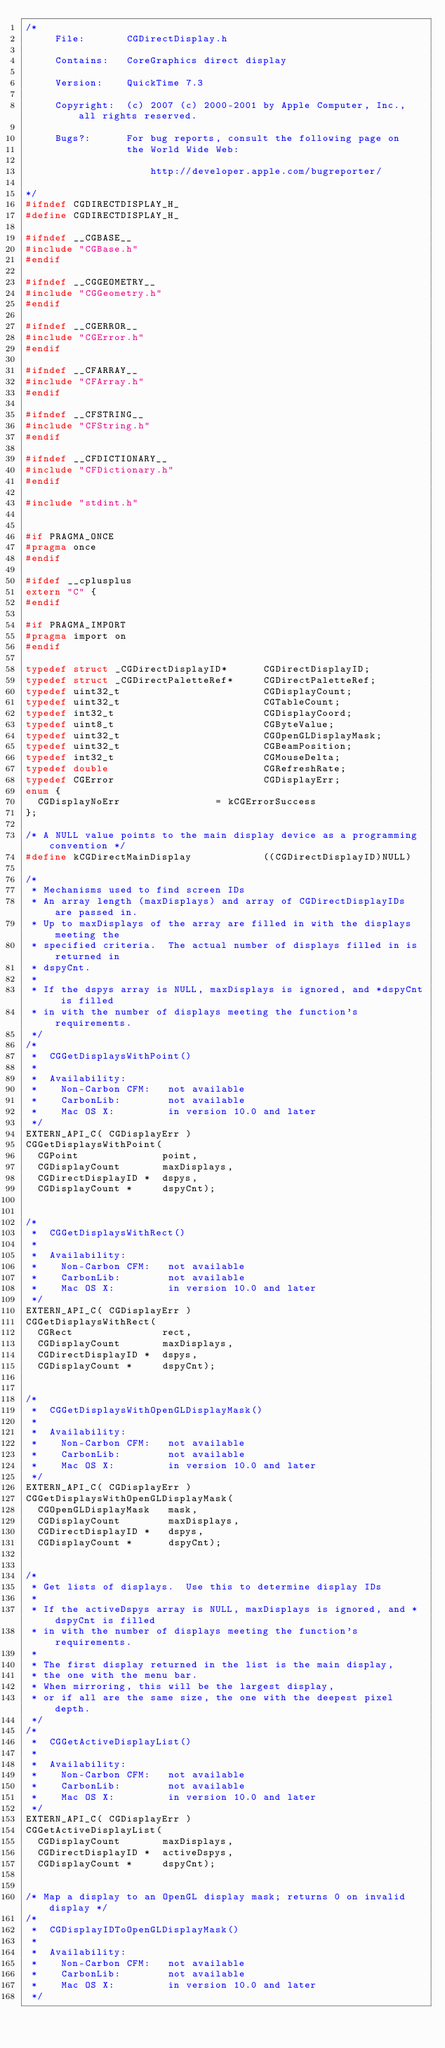Convert code to text. <code><loc_0><loc_0><loc_500><loc_500><_C_>/*
     File:       CGDirectDisplay.h
 
     Contains:   CoreGraphics direct display
 
     Version:    QuickTime 7.3
 
     Copyright:  (c) 2007 (c) 2000-2001 by Apple Computer, Inc., all rights reserved.
 
     Bugs?:      For bug reports, consult the following page on
                 the World Wide Web:
 
                     http://developer.apple.com/bugreporter/
 
*/
#ifndef CGDIRECTDISPLAY_H_
#define CGDIRECTDISPLAY_H_

#ifndef __CGBASE__
#include "CGBase.h"
#endif

#ifndef __CGGEOMETRY__
#include "CGGeometry.h"
#endif

#ifndef __CGERROR__
#include "CGError.h"
#endif

#ifndef __CFARRAY__
#include "CFArray.h"
#endif

#ifndef __CFSTRING__
#include "CFString.h"
#endif

#ifndef __CFDICTIONARY__
#include "CFDictionary.h"
#endif

#include "stdint.h"


#if PRAGMA_ONCE
#pragma once
#endif

#ifdef __cplusplus
extern "C" {
#endif

#if PRAGMA_IMPORT
#pragma import on
#endif

typedef struct _CGDirectDisplayID*      CGDirectDisplayID;
typedef struct _CGDirectPaletteRef*     CGDirectPaletteRef;
typedef uint32_t                        CGDisplayCount;
typedef uint32_t                        CGTableCount;
typedef int32_t                         CGDisplayCoord;
typedef uint8_t                         CGByteValue;
typedef uint32_t                        CGOpenGLDisplayMask;
typedef uint32_t                        CGBeamPosition;
typedef int32_t                         CGMouseDelta;
typedef double                          CGRefreshRate;
typedef CGError                         CGDisplayErr;
enum {
  CGDisplayNoErr                = kCGErrorSuccess
};

/* A NULL value points to the main display device as a programming convention */
#define kCGDirectMainDisplay            ((CGDirectDisplayID)NULL)

/*
 * Mechanisms used to find screen IDs
 * An array length (maxDisplays) and array of CGDirectDisplayIDs are passed in.
 * Up to maxDisplays of the array are filled in with the displays meeting the
 * specified criteria.  The actual number of displays filled in is returned in
 * dspyCnt.
 *
 * If the dspys array is NULL, maxDisplays is ignored, and *dspyCnt is filled
 * in with the number of displays meeting the function's requirements.
 */
/*
 *  CGGetDisplaysWithPoint()
 *  
 *  Availability:
 *    Non-Carbon CFM:   not available
 *    CarbonLib:        not available
 *    Mac OS X:         in version 10.0 and later
 */
EXTERN_API_C( CGDisplayErr )
CGGetDisplaysWithPoint(
  CGPoint              point,
  CGDisplayCount       maxDisplays,
  CGDirectDisplayID *  dspys,
  CGDisplayCount *     dspyCnt);


/*
 *  CGGetDisplaysWithRect()
 *  
 *  Availability:
 *    Non-Carbon CFM:   not available
 *    CarbonLib:        not available
 *    Mac OS X:         in version 10.0 and later
 */
EXTERN_API_C( CGDisplayErr )
CGGetDisplaysWithRect(
  CGRect               rect,
  CGDisplayCount       maxDisplays,
  CGDirectDisplayID *  dspys,
  CGDisplayCount *     dspyCnt);


/*
 *  CGGetDisplaysWithOpenGLDisplayMask()
 *  
 *  Availability:
 *    Non-Carbon CFM:   not available
 *    CarbonLib:        not available
 *    Mac OS X:         in version 10.0 and later
 */
EXTERN_API_C( CGDisplayErr )
CGGetDisplaysWithOpenGLDisplayMask(
  CGOpenGLDisplayMask   mask,
  CGDisplayCount        maxDisplays,
  CGDirectDisplayID *   dspys,
  CGDisplayCount *      dspyCnt);


/*
 * Get lists of displays.  Use this to determine display IDs
 *
 * If the activeDspys array is NULL, maxDisplays is ignored, and *dspyCnt is filled
 * in with the number of displays meeting the function's requirements.
 *
 * The first display returned in the list is the main display,
 * the one with the menu bar.
 * When mirroring, this will be the largest display,
 * or if all are the same size, the one with the deepest pixel depth.
 */
/*
 *  CGGetActiveDisplayList()
 *  
 *  Availability:
 *    Non-Carbon CFM:   not available
 *    CarbonLib:        not available
 *    Mac OS X:         in version 10.0 and later
 */
EXTERN_API_C( CGDisplayErr )
CGGetActiveDisplayList(
  CGDisplayCount       maxDisplays,
  CGDirectDisplayID *  activeDspys,
  CGDisplayCount *     dspyCnt);


/* Map a display to an OpenGL display mask; returns 0 on invalid display */
/*
 *  CGDisplayIDToOpenGLDisplayMask()
 *  
 *  Availability:
 *    Non-Carbon CFM:   not available
 *    CarbonLib:        not available
 *    Mac OS X:         in version 10.0 and later
 */</code> 